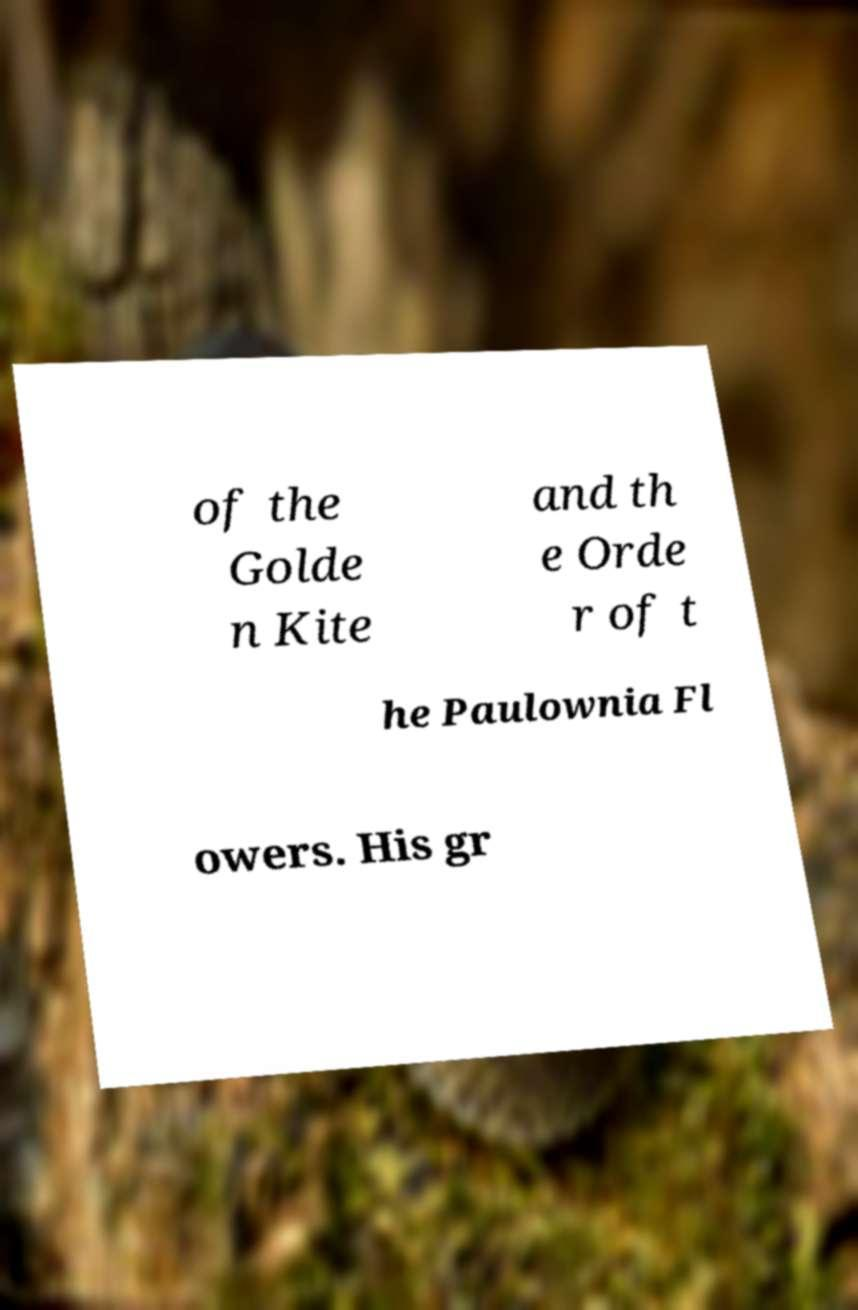Could you extract and type out the text from this image? of the Golde n Kite and th e Orde r of t he Paulownia Fl owers. His gr 